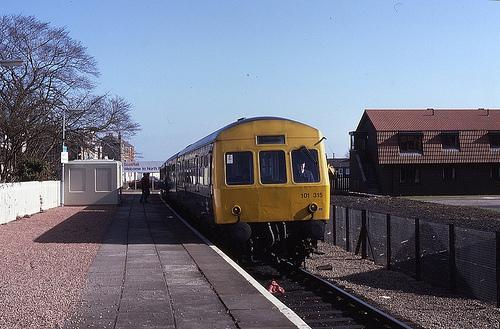Question: where was this taken?
Choices:
A. At home.
B. Train station.
C. In the garden.
D. At the beach.
Answer with the letter. Answer: B Question: what color is the train?
Choices:
A. Yellow.
B. Black.
C. Gray.
D. White.
Answer with the letter. Answer: A 